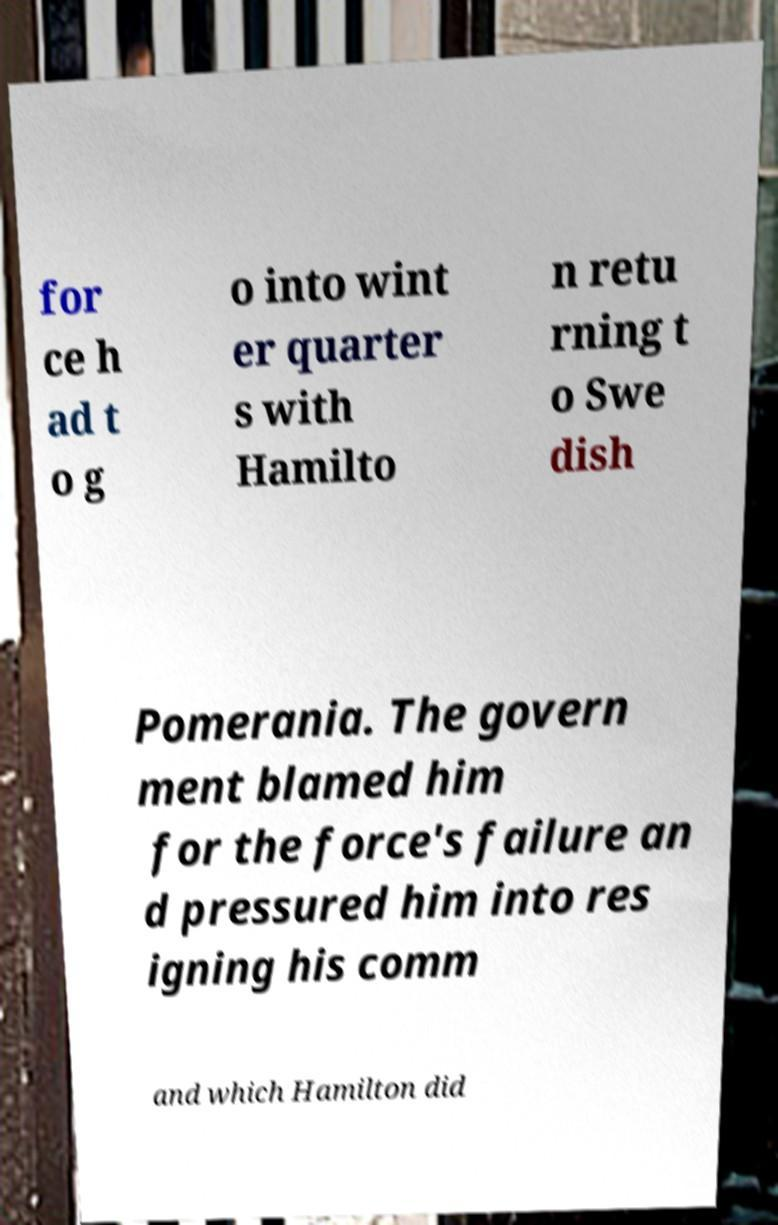For documentation purposes, I need the text within this image transcribed. Could you provide that? for ce h ad t o g o into wint er quarter s with Hamilto n retu rning t o Swe dish Pomerania. The govern ment blamed him for the force's failure an d pressured him into res igning his comm and which Hamilton did 